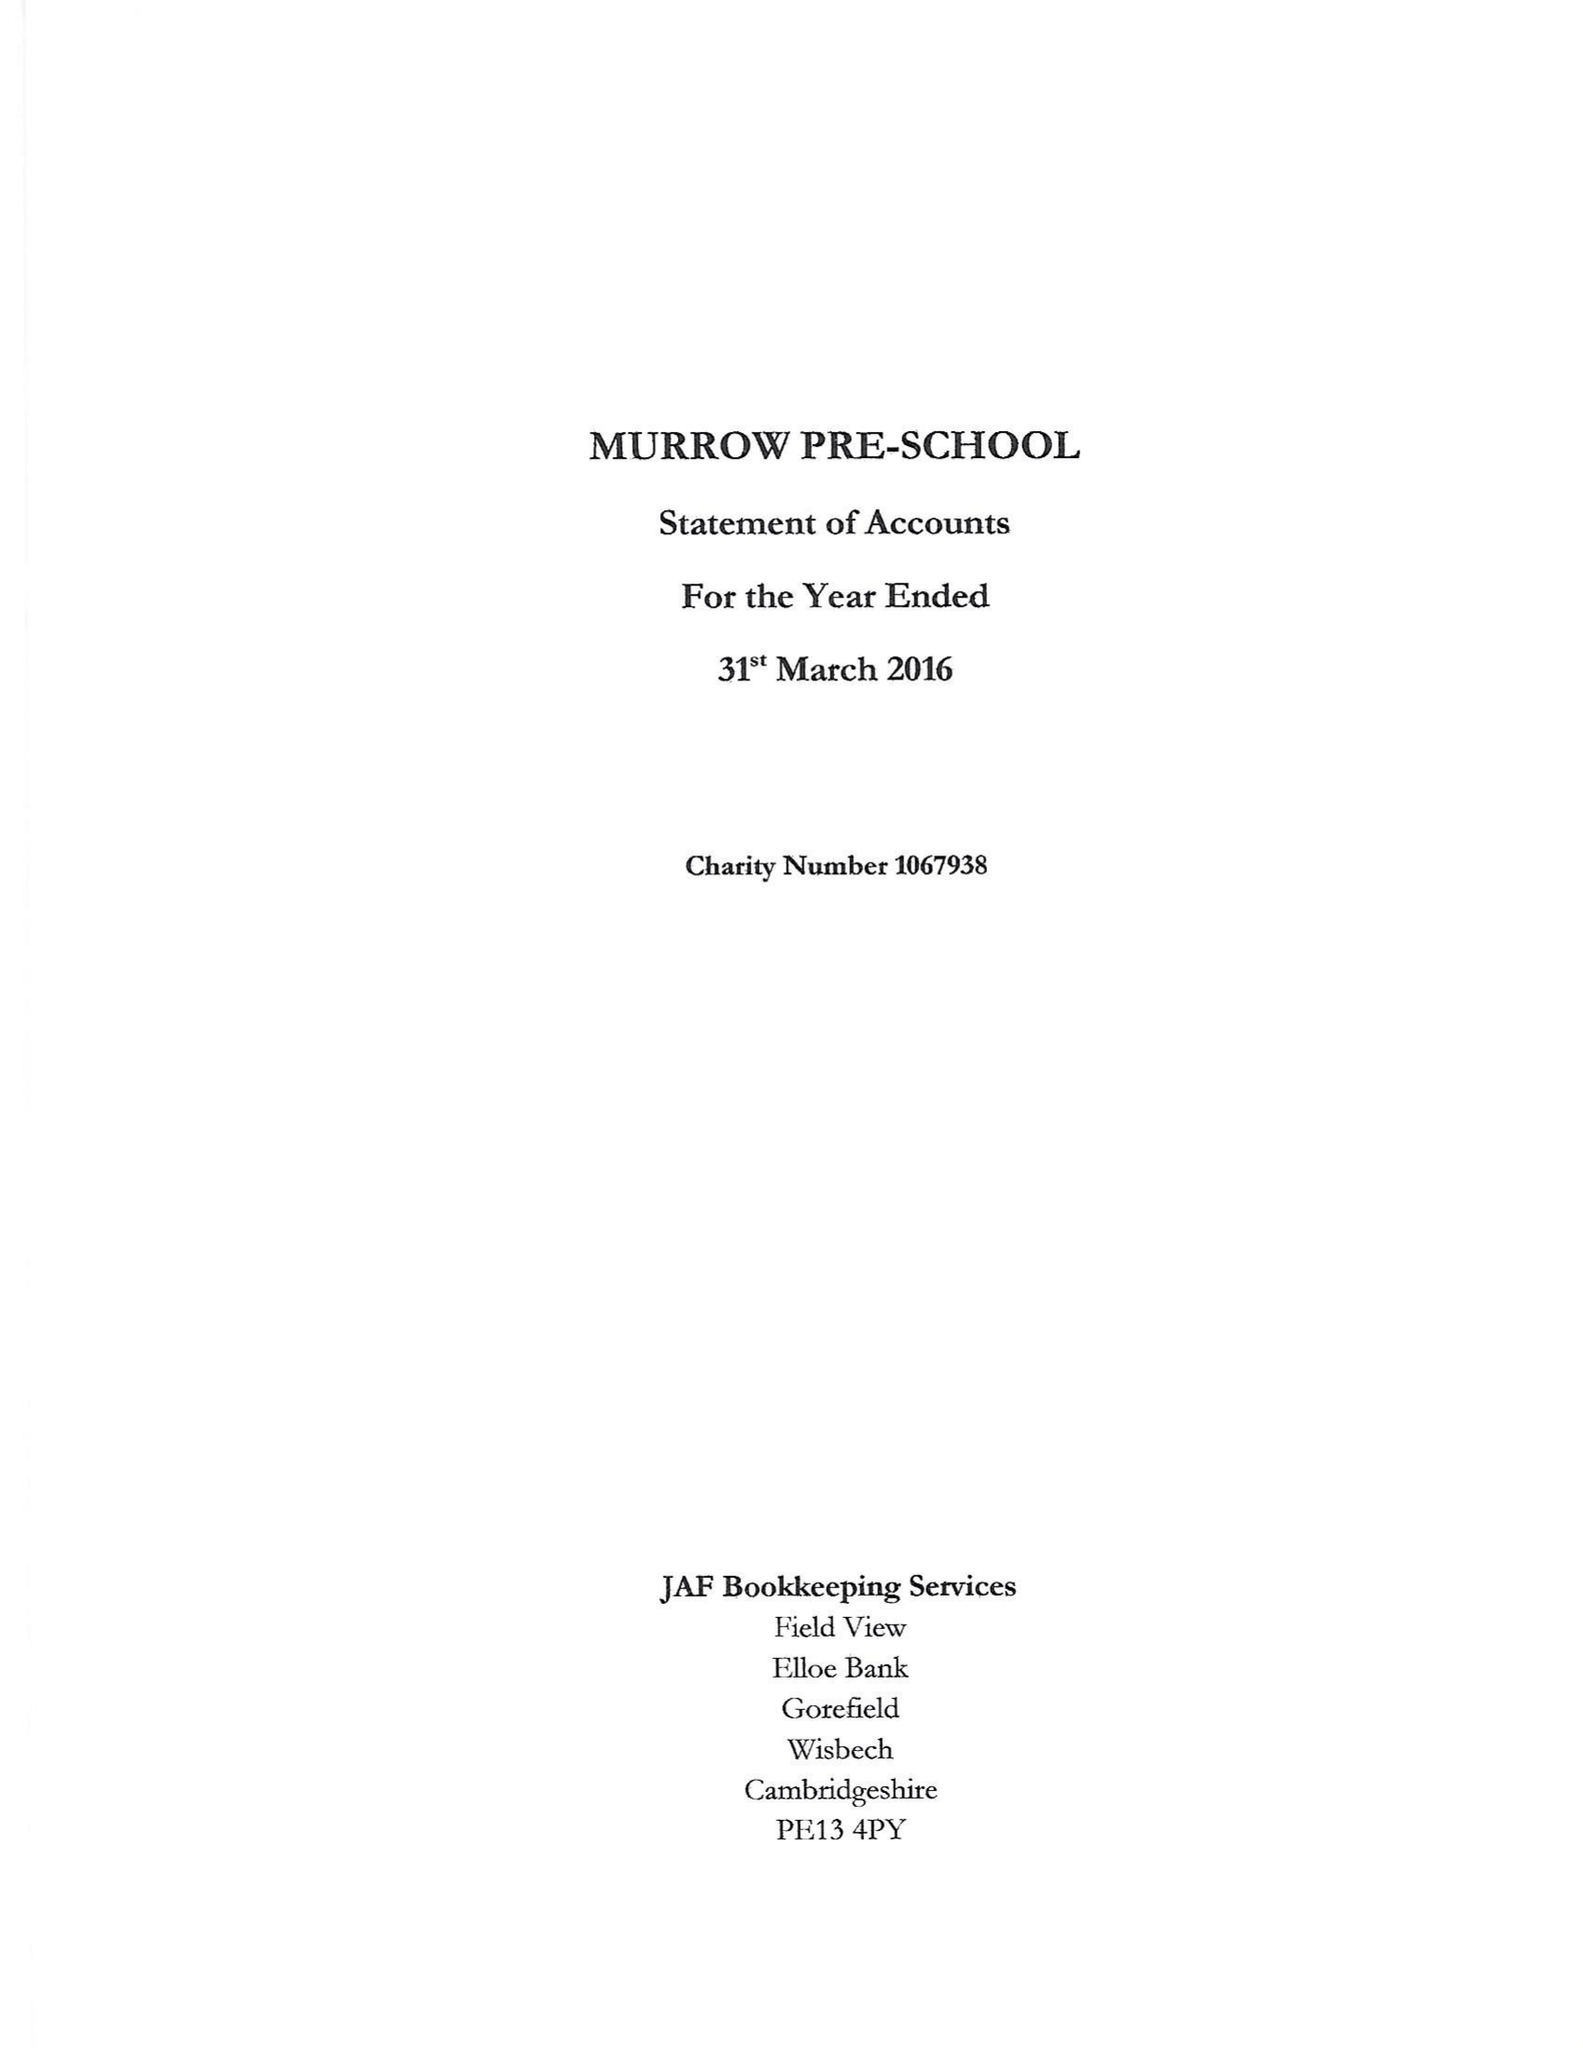What is the value for the address__post_town?
Answer the question using a single word or phrase. WISBECH 